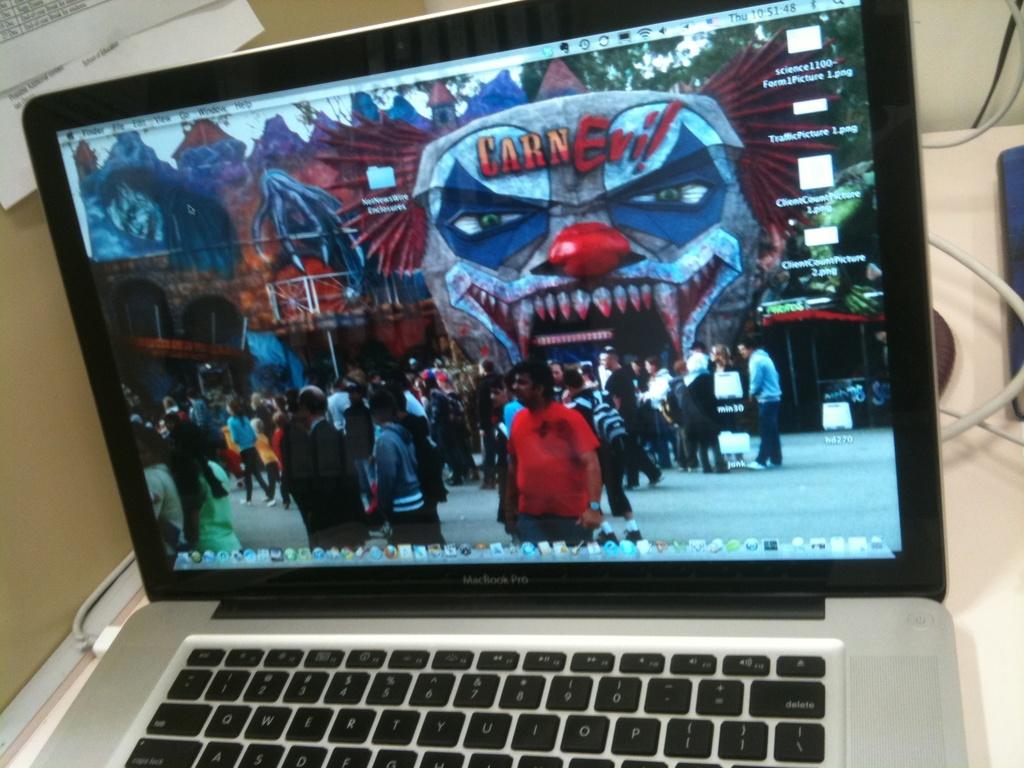What brand of laptop is this?
Keep it short and to the point. Macbook pro. 